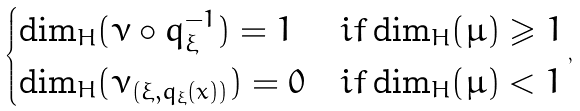Convert formula to latex. <formula><loc_0><loc_0><loc_500><loc_500>\begin{cases} \dim _ { H } ( \nu \circ q _ { \xi } ^ { - 1 } ) = 1 & i f \dim _ { H } ( \mu ) \geqslant 1 \\ \dim _ { H } ( \nu _ { ( \xi , q _ { \xi } ( x ) ) } ) = 0 & i f \dim _ { H } ( \mu ) < 1 \end{cases} ,</formula> 